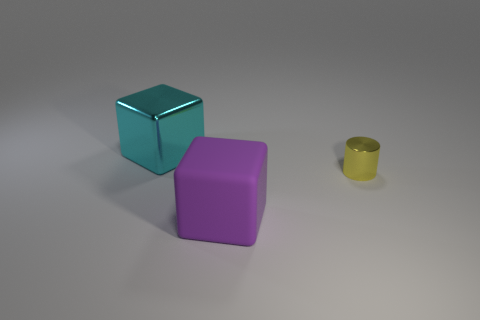Add 3 yellow cylinders. How many objects exist? 6 Subtract all cyan blocks. How many blocks are left? 1 Subtract all cylinders. How many objects are left? 2 Subtract 1 blocks. How many blocks are left? 1 Subtract all blue cylinders. Subtract all gray cubes. How many cylinders are left? 1 Subtract 0 green cylinders. How many objects are left? 3 Subtract all green cylinders. How many purple blocks are left? 1 Subtract all matte things. Subtract all metal blocks. How many objects are left? 1 Add 1 big purple blocks. How many big purple blocks are left? 2 Add 1 large red balls. How many large red balls exist? 1 